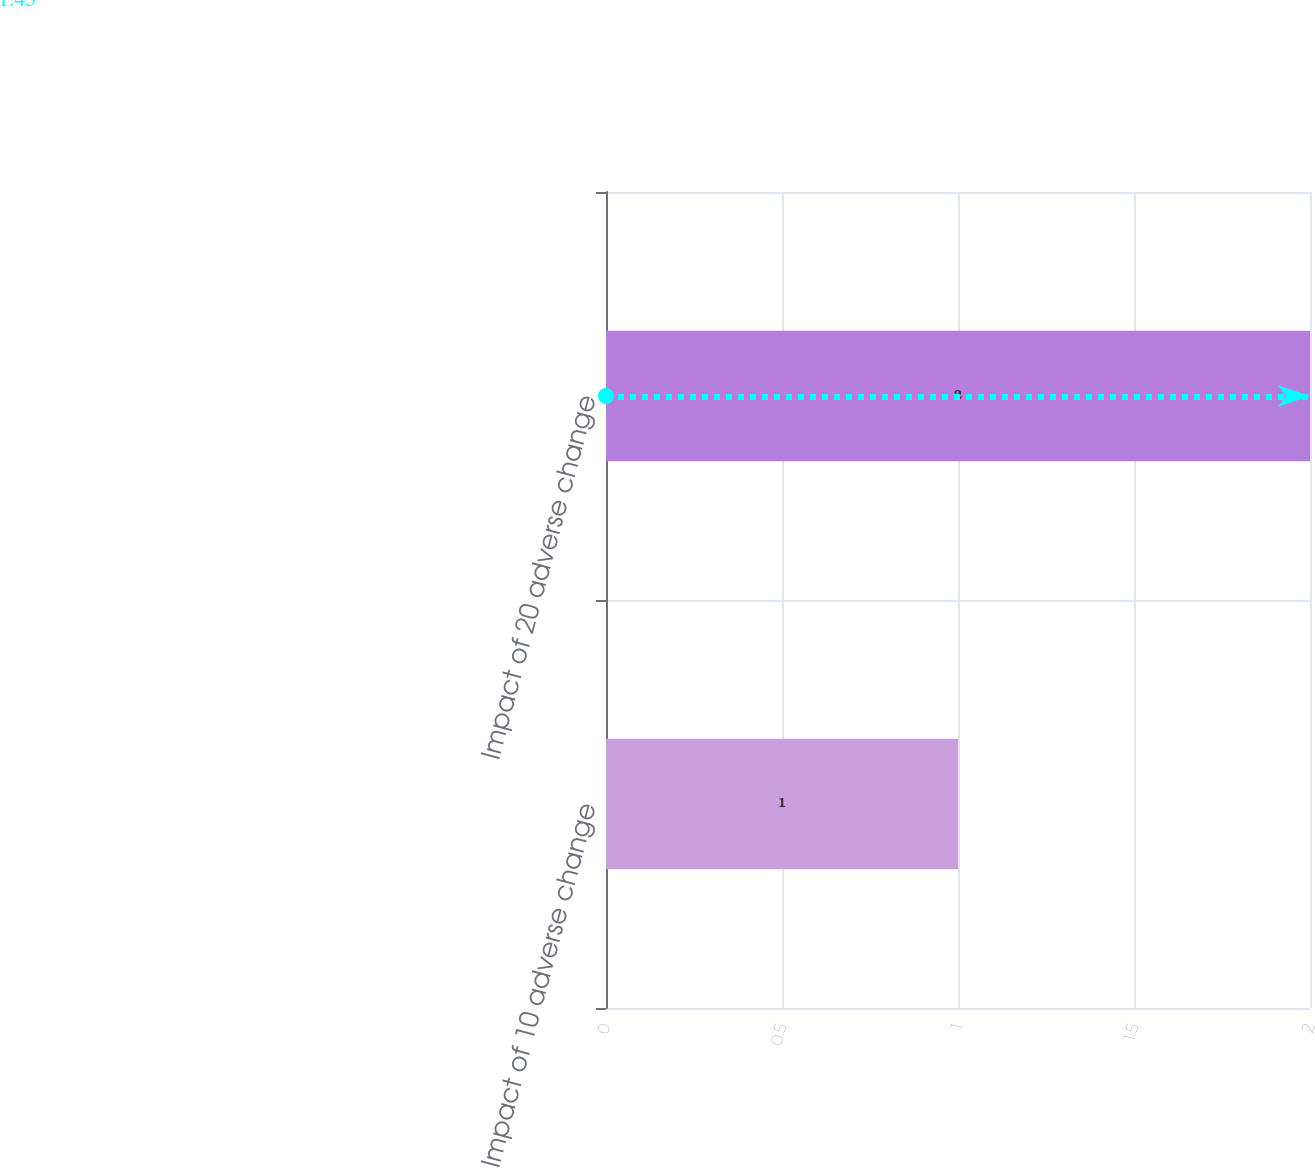<chart> <loc_0><loc_0><loc_500><loc_500><bar_chart><fcel>Impact of 10 adverse change<fcel>Impact of 20 adverse change<nl><fcel>1<fcel>2<nl></chart> 